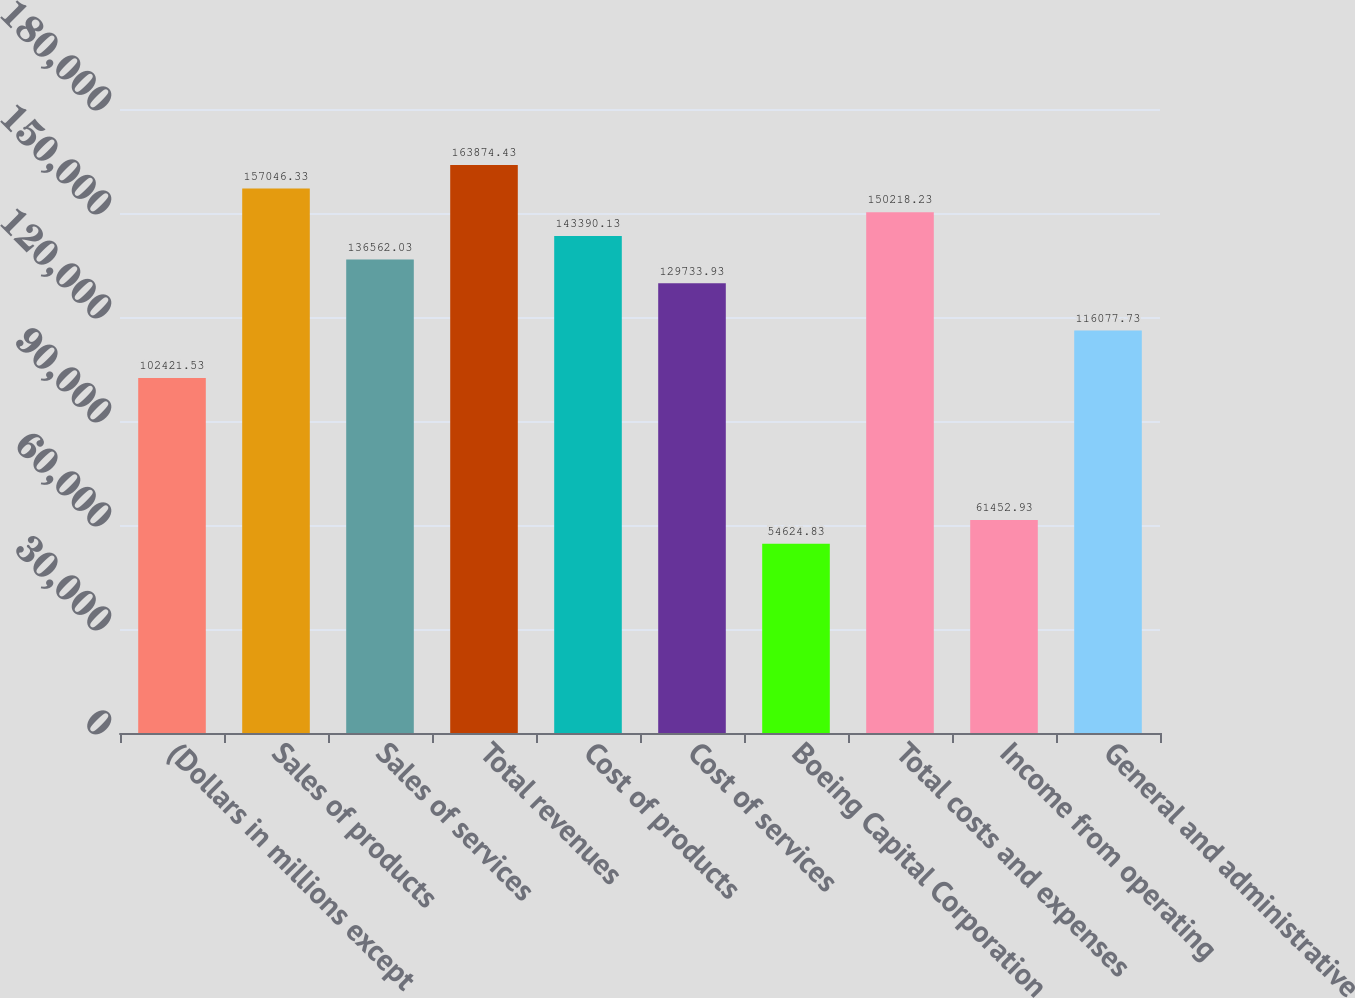<chart> <loc_0><loc_0><loc_500><loc_500><bar_chart><fcel>(Dollars in millions except<fcel>Sales of products<fcel>Sales of services<fcel>Total revenues<fcel>Cost of products<fcel>Cost of services<fcel>Boeing Capital Corporation<fcel>Total costs and expenses<fcel>Income from operating<fcel>General and administrative<nl><fcel>102422<fcel>157046<fcel>136562<fcel>163874<fcel>143390<fcel>129734<fcel>54624.8<fcel>150218<fcel>61452.9<fcel>116078<nl></chart> 